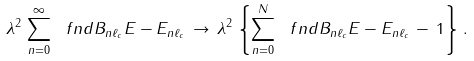<formula> <loc_0><loc_0><loc_500><loc_500>\lambda ^ { 2 } \, \sum _ { n = 0 } ^ { \infty } \ f n d { B _ { n \ell _ { c } } } { E - E _ { n \ell _ { c } } } \, \rightarrow \, \lambda ^ { 2 } \, \left \{ \sum _ { n = 0 } ^ { N } \ f n d { B _ { n \ell _ { c } } } { E - E _ { n \ell _ { c } } } \, - \, 1 \right \} \, .</formula> 